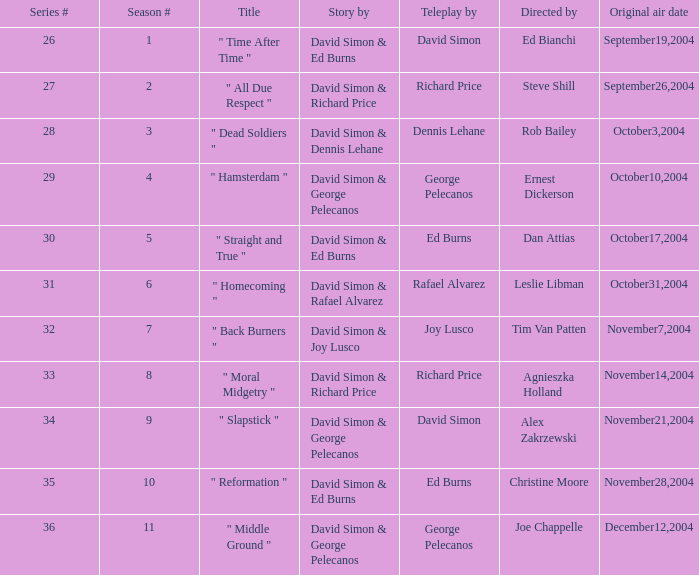What is the season figure for a tv script composed by richard price and having steve shill as the director? 2.0. 